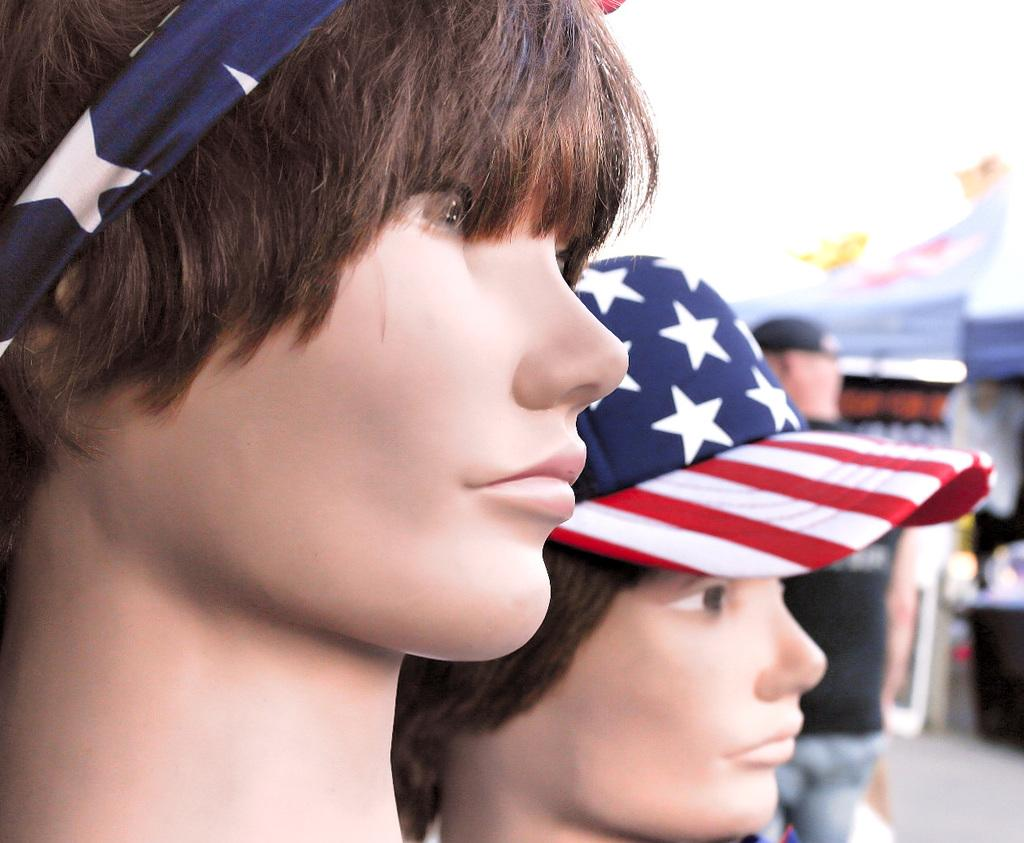How many mannequins are present in the image? There are two mannequins in the image. What are the mannequins wearing on their heads? Each mannequin has a hat. Can you describe the background of the mannequins? The background of the mannequins is blurred. What type of bike is being polished in the image? There is no bike present in the image, nor is there any polishing activity taking place. 